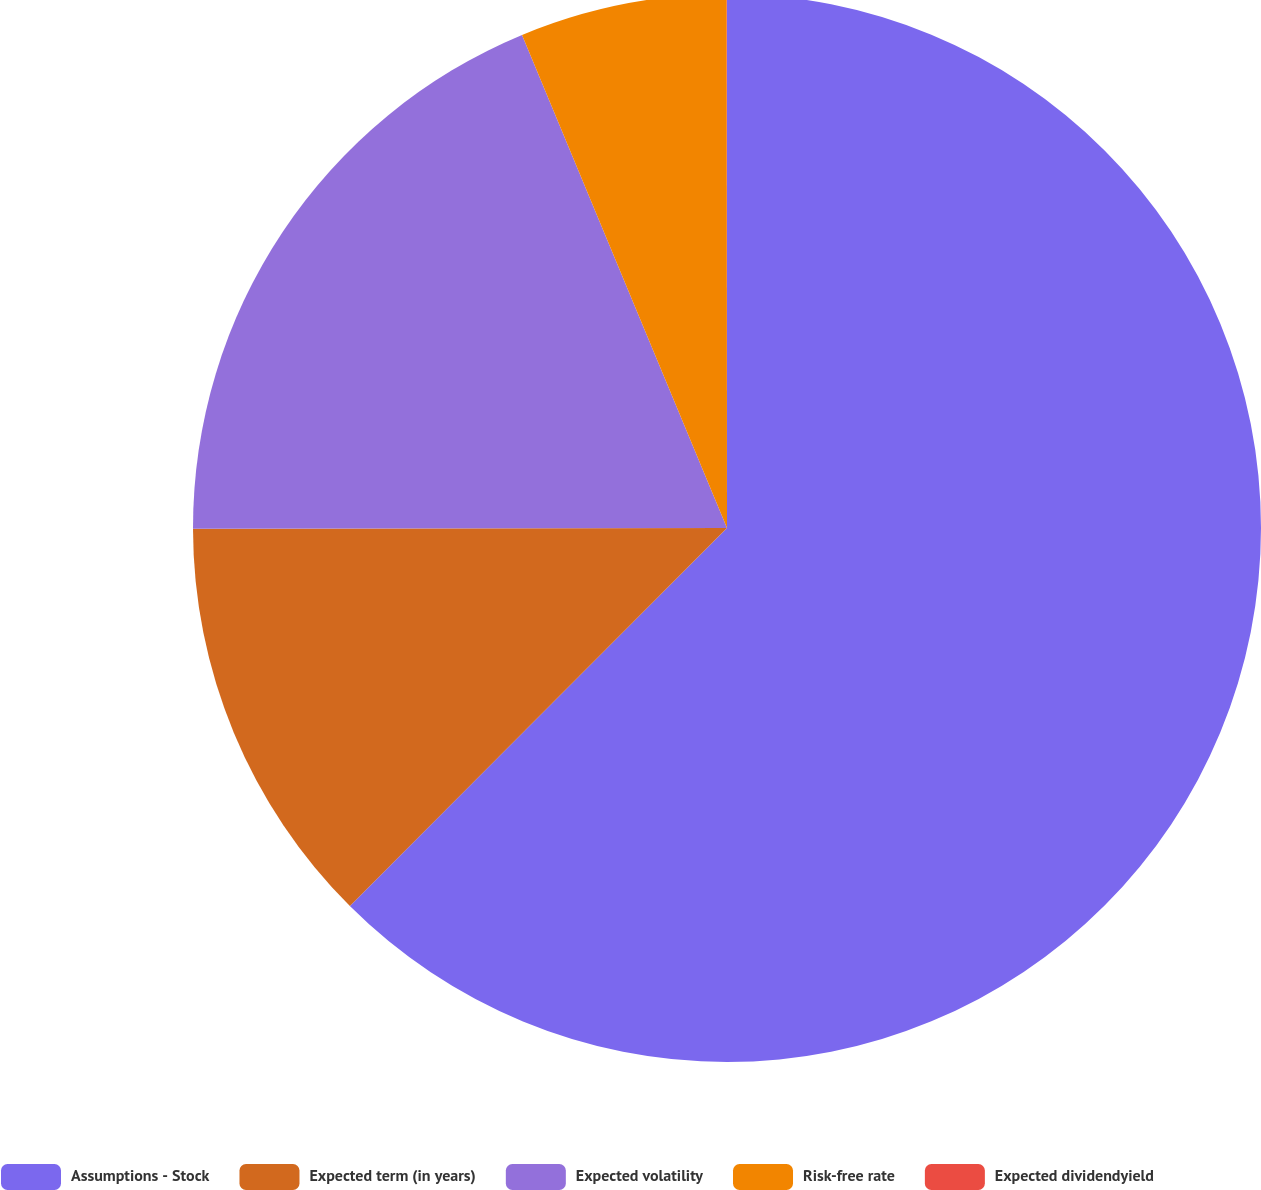<chart> <loc_0><loc_0><loc_500><loc_500><pie_chart><fcel>Assumptions - Stock<fcel>Expected term (in years)<fcel>Expected volatility<fcel>Risk-free rate<fcel>Expected dividendyield<nl><fcel>62.48%<fcel>12.5%<fcel>18.75%<fcel>6.26%<fcel>0.01%<nl></chart> 